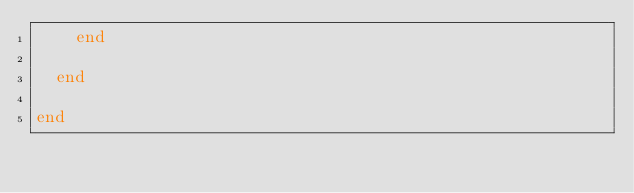<code> <loc_0><loc_0><loc_500><loc_500><_Elixir_>    end

  end

end
</code> 